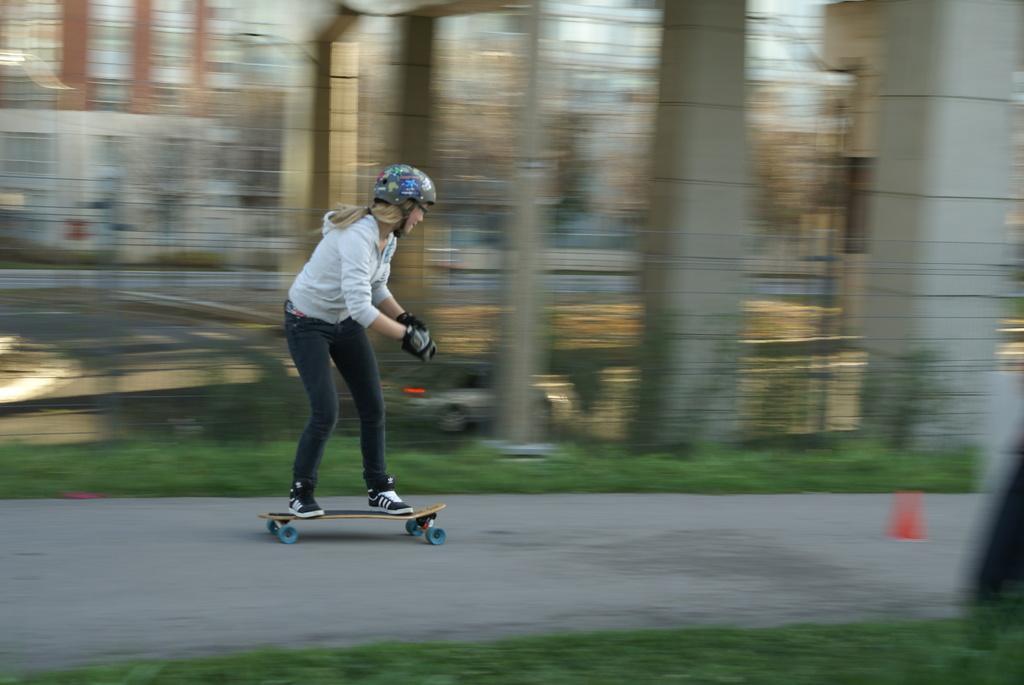In one or two sentences, can you explain what this image depicts? In this picture there is a woman wearing a white shirt and a black jeans with black helmet on the head is doing the skating on the road. Behind there is a blur background. 